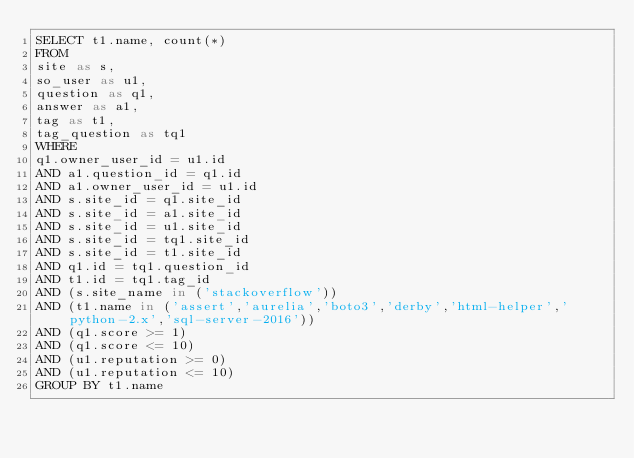<code> <loc_0><loc_0><loc_500><loc_500><_SQL_>SELECT t1.name, count(*)
FROM
site as s,
so_user as u1,
question as q1,
answer as a1,
tag as t1,
tag_question as tq1
WHERE
q1.owner_user_id = u1.id
AND a1.question_id = q1.id
AND a1.owner_user_id = u1.id
AND s.site_id = q1.site_id
AND s.site_id = a1.site_id
AND s.site_id = u1.site_id
AND s.site_id = tq1.site_id
AND s.site_id = t1.site_id
AND q1.id = tq1.question_id
AND t1.id = tq1.tag_id
AND (s.site_name in ('stackoverflow'))
AND (t1.name in ('assert','aurelia','boto3','derby','html-helper','python-2.x','sql-server-2016'))
AND (q1.score >= 1)
AND (q1.score <= 10)
AND (u1.reputation >= 0)
AND (u1.reputation <= 10)
GROUP BY t1.name</code> 